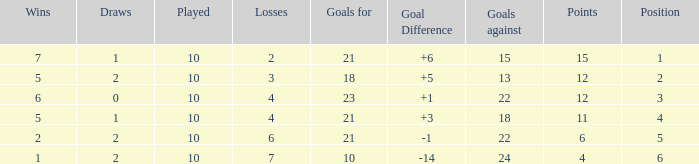Can you tell me the lowest Played that has the Position larger than 2, and the Draws smaller than 2, and the Goals against smaller than 18? None. 